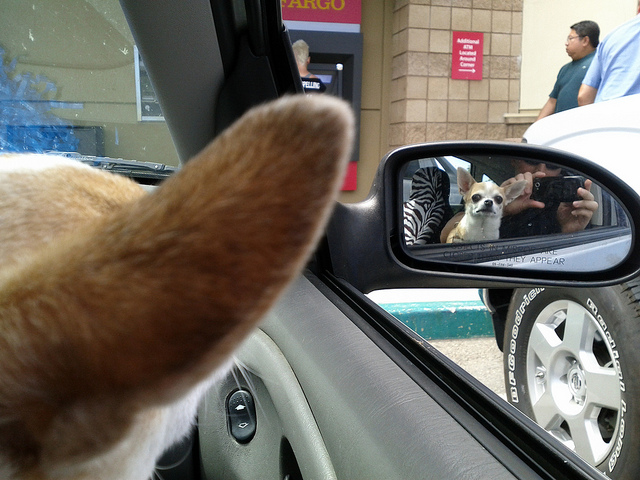Identify the text contained in this image. FARGO APPEAR 